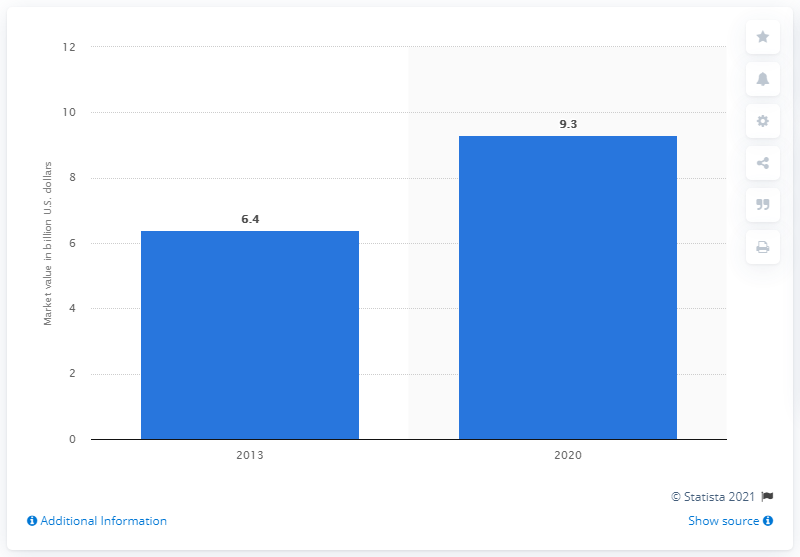Mention a couple of crucial points in this snapshot. The value of the rheumatoid arthritis treatment market in 2013 was 6.4 billion dollars. By 2020, it was expected that the rheumatoid arthritis treatment market would grow to approximately 9.3%. 